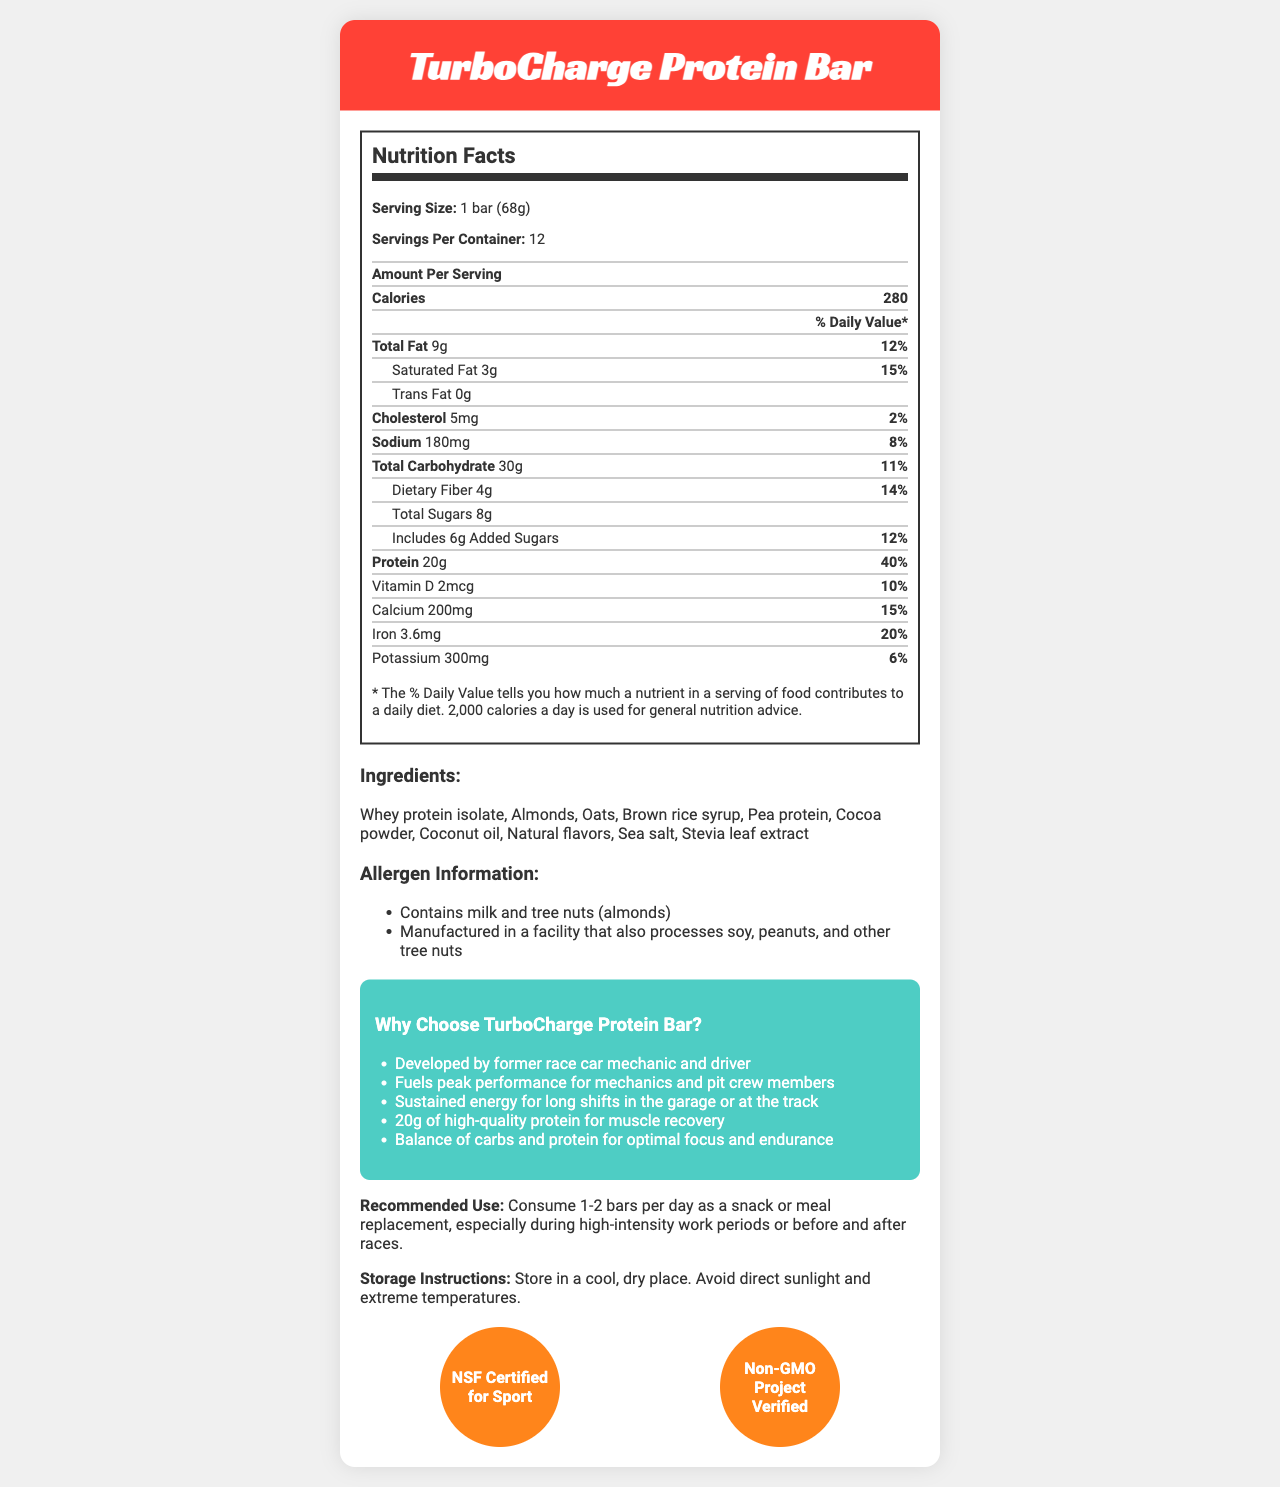how many servings are in one container of TurboCharge Protein Bar? According to the Nutrition Facts, there are 12 servings per container.
Answer: 12 what is the amount of protein per serving? The Nutrition Facts section shows that each serving contains 20g of protein.
Answer: 20g which ingredient is used as a sweetener in TurboCharge Protein Bar? The ingredients list includes both brown rice syrup and Stevia leaf extract as sweeteners.
Answer: Brown rice syrup and Stevia leaf extract how much saturated fat is in one bar? According to the Nutrition Facts, one bar contains 3g of saturated fat.
Answer: 3g what is the recommended daily use for TurboCharge Protein Bar? The document explicitly states the recommended use in the designated section.
Answer: Consume 1-2 bars per day as a snack or meal replacement, especially during high-intensity work periods or before and after races. how much calcium does one bar provide? The Nutrition Facts section indicates that one bar provides 200mg of calcium.
Answer: 200mg which certifications does TurboCharge Protein Bar have? The Certifications section lists NSF Certified for Sport and Non-GMO Project Verified.
Answer: NSF Certified for Sport, Non-GMO Project Verified does TurboCharge Protein Bar contain any allergens? The allergens listed in the document are milk and tree nuts (almonds).
Answer: Yes does the product include artificial flavors? The ingredients list mentions "Natural flavors," implying no artificial flavors.
Answer: No what is the daily value percentage of sodium in TurboCharge Protein Bar? The Nutrition Facts table indicates that the daily value percentage for sodium is 8%.
Answer: 8% how should TurboCharge Protein Bars be stored? The Storage Instructions section provides this information.
Answer: Store in a cool, dry place. Avoid direct sunlight and extreme temperatures. who developed TurboCharge Protein Bar? A. A nutritionist B. A fitness trainer C. A former race car mechanic and driver D. A chef The marketing claims mention that the product was developed by a former race car mechanic and driver.
Answer: C what is the primary focus of TurboCharge Protein Bar, according to its marketing claims? A. Weight loss B. Peak performance and muscle recovery for mechanics and pit crew members C. Low-calorie snacks D. Meal replacement for general public The marketing claims emphasize peak performance and muscle recovery for mechanics and pit crew members.
Answer: B is TurboCharge Protein Bar suitable for someone allergic to peanuts? The allergen information states that it is manufactured in a facility that also processes soy, peanuts, and other tree nuts.
Answer: No summarize the main information provided in the document. The document covers detailed nutritional information, ingredient list, allergens, marketing claims, recommended use, storage instructions, and certifications for the TurboCharge Protein Bar.
Answer: The TurboCharge Protein Bar is specifically designed for mechanics and pit crew members, offering 20g of protein per serving and packed with essential vitamins and minerals. It contains natural ingredients like whey protein isolate, almonds, oats, and is marketed for sustaining energy and improving muscle recovery. The bar is NSF Certified for Sport and Non-GMO Project Verified, and consumers are advised to store it in a cool, dry place. what is the daily value percentage of iron for a 2,000 calorie diet provided by one TurboCharge Protein Bar? The Nutrition Facts table lists the daily value percentage of iron as 20%.
Answer: 20% how many grams of dietary fiber does one bar contain? According to the Nutrition Facts, one bar contains 4g of dietary fiber.
Answer: 4g what is the main source of protein in the TurboCharge Protein Bar? The ingredients list shows whey protein isolate and pea protein as the main sources of protein.
Answer: Whey protein isolate and pea protein is the product Non-GMO certified? The Certifications section indicates that the product is Non-GMO Project Verified.
Answer: Yes how many calories are in one serving of TurboCharge Protein Bar? The Nutrition Facts section states that there are 280 calories per serving.
Answer: 280 does the document mention the bar's ability to hydrate the consumer? The document does not provide any information about hydration or hydration-related benefits.
Answer: Not enough information 